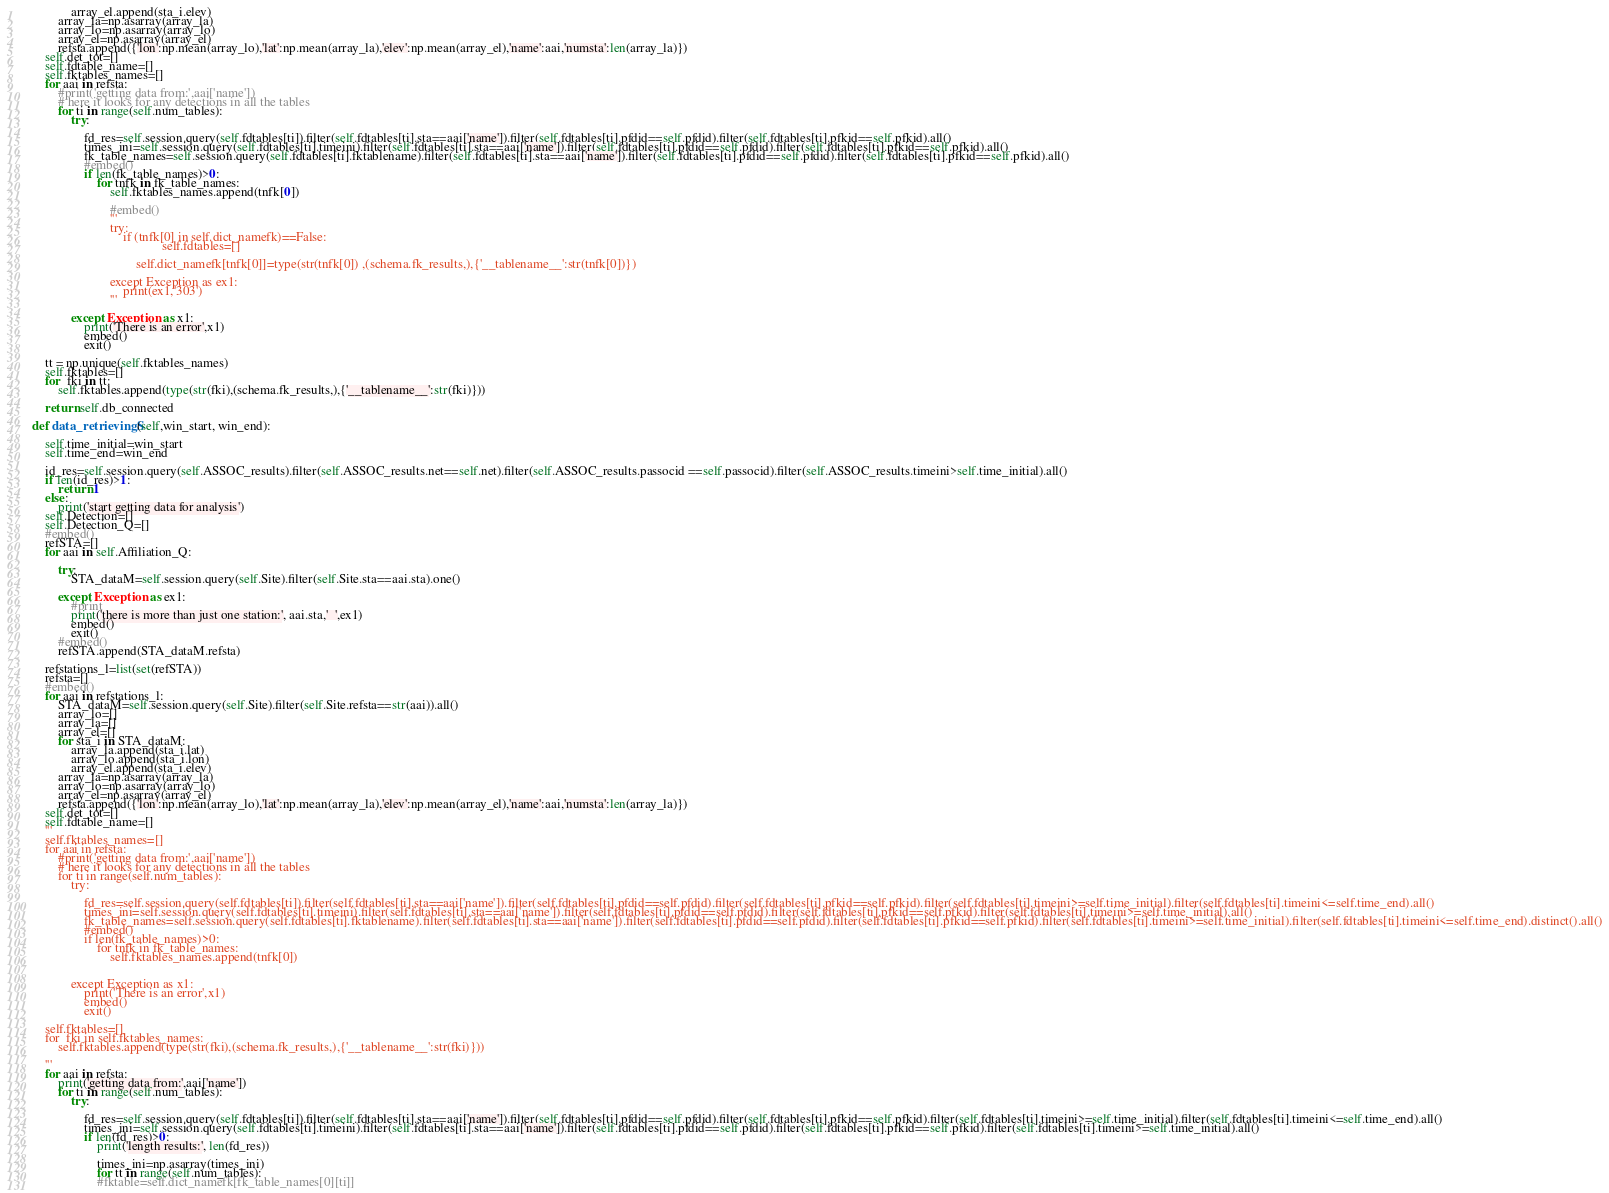<code> <loc_0><loc_0><loc_500><loc_500><_Python_>                array_el.append(sta_i.elev)
            array_la=np.asarray(array_la)
            array_lo=np.asarray(array_lo)
            array_el=np.asarray(array_el)
            refsta.append({'lon':np.mean(array_lo),'lat':np.mean(array_la),'elev':np.mean(array_el),'name':aai,'numsta':len(array_la)})
        self.det_tot=[]
        self.fdtable_name=[]
        self.fktables_names=[]
        for aai in refsta:
            #print('getting data from:',aai['name'])
            # here it looks for any detections in all the tables
            for ti in range(self.num_tables):
                try:

                    fd_res=self.session.query(self.fdtables[ti]).filter(self.fdtables[ti].sta==aai['name']).filter(self.fdtables[ti].pfdid==self.pfdid).filter(self.fdtables[ti].pfkid==self.pfkid).all()
                    times_ini=self.session.query(self.fdtables[ti].timeini).filter(self.fdtables[ti].sta==aai['name']).filter(self.fdtables[ti].pfdid==self.pfdid).filter(self.fdtables[ti].pfkid==self.pfkid).all()
                    fk_table_names=self.session.query(self.fdtables[ti].fktablename).filter(self.fdtables[ti].sta==aai['name']).filter(self.fdtables[ti].pfdid==self.pfdid).filter(self.fdtables[ti].pfkid==self.pfkid).all()
                    #embed()
                    if len(fk_table_names)>0:
                        for tnfk in fk_table_names:
                            self.fktables_names.append(tnfk[0])

                            #embed()
                            '''
                            try:
                                if (tnfk[0] in self.dict_namefk)==False:
                                            self.fdtables=[]

                                    self.dict_namefk[tnfk[0]]=type(str(tnfk[0]) ,(schema.fk_results,),{'__tablename__':str(tnfk[0])})

                            except Exception as ex1:
                                print(ex1,'303')
                            '''

                except Exception as x1:
                    print('There is an error',x1)
                    embed()
                    exit()

        tt = np.unique(self.fktables_names)
        self.fktables=[]
        for  fki in tt:
            self.fktables.append(type(str(fki),(schema.fk_results,),{'__tablename__':str(fki)}))

        return self.db_connected

    def data_retrievingS(self,win_start, win_end):

        self.time_initial=win_start
        self.time_end=win_end

        id_res=self.session.query(self.ASSOC_results).filter(self.ASSOC_results.net==self.net).filter(self.ASSOC_results.passocid ==self.passocid).filter(self.ASSOC_results.timeini>self.time_initial).all()
        if len(id_res)>1:
            return 1
        else:
            print('start getting data for analysis')
        self.Detection=[]
        self.Detection_Q=[]
        #embed()
        refSTA=[]
        for aai in self.Affiliation_Q:

            try:
                STA_dataM=self.session.query(self.Site).filter(self.Site.sta==aai.sta).one()

            except Exception as ex1:
                #print
                print('there is more than just one station:', aai.sta,'  ',ex1)
                embed()
                exit()
            #embed()
            refSTA.append(STA_dataM.refsta)

        refstations_l=list(set(refSTA))
        refsta=[]
        #embed()
        for aai in refstations_l:
            STA_dataM=self.session.query(self.Site).filter(self.Site.refsta==str(aai)).all()
            array_lo=[]
            array_la=[]
            array_el=[]
            for sta_i in STA_dataM:
                array_la.append(sta_i.lat)
                array_lo.append(sta_i.lon)
                array_el.append(sta_i.elev)
            array_la=np.asarray(array_la)
            array_lo=np.asarray(array_lo)
            array_el=np.asarray(array_el)
            refsta.append({'lon':np.mean(array_lo),'lat':np.mean(array_la),'elev':np.mean(array_el),'name':aai,'numsta':len(array_la)})
        self.det_tot=[]
        self.fdtable_name=[]
        '''
        self.fktables_names=[]
        for aai in refsta:
            #print('getting data from:',aai['name'])
            # here it looks for any detections in all the tables
            for ti in range(self.num_tables):
                try:

                    fd_res=self.session.query(self.fdtables[ti]).filter(self.fdtables[ti].sta==aai['name']).filter(self.fdtables[ti].pfdid==self.pfdid).filter(self.fdtables[ti].pfkid==self.pfkid).filter(self.fdtables[ti].timeini>=self.time_initial).filter(self.fdtables[ti].timeini<=self.time_end).all()
                    times_ini=self.session.query(self.fdtables[ti].timeini).filter(self.fdtables[ti].sta==aai['name']).filter(self.fdtables[ti].pfdid==self.pfdid).filter(self.fdtables[ti].pfkid==self.pfkid).filter(self.fdtables[ti].timeini>=self.time_initial).all()
                    fk_table_names=self.session.query(self.fdtables[ti].fktablename).filter(self.fdtables[ti].sta==aai['name']).filter(self.fdtables[ti].pfdid==self.pfdid).filter(self.fdtables[ti].pfkid==self.pfkid).filter(self.fdtables[ti].timeini>=self.time_initial).filter(self.fdtables[ti].timeini<=self.time_end).distinct().all()
                    #embed()
                    if len(fk_table_names)>0:
                        for tnfk in fk_table_names:
                            self.fktables_names.append(tnfk[0])


                except Exception as x1:
                    print('There is an error',x1)
                    embed()
                    exit()

        self.fktables=[]
        for  fki in self.fktables_names:
            self.fktables.append(type(str(fki),(schema.fk_results,),{'__tablename__':str(fki)}))

        '''
        for aai in refsta:
            print('getting data from:',aai['name'])
            for ti in range(self.num_tables):
                try:

                    fd_res=self.session.query(self.fdtables[ti]).filter(self.fdtables[ti].sta==aai['name']).filter(self.fdtables[ti].pfdid==self.pfdid).filter(self.fdtables[ti].pfkid==self.pfkid).filter(self.fdtables[ti].timeini>=self.time_initial).filter(self.fdtables[ti].timeini<=self.time_end).all()
                    times_ini=self.session.query(self.fdtables[ti].timeini).filter(self.fdtables[ti].sta==aai['name']).filter(self.fdtables[ti].pfdid==self.pfdid).filter(self.fdtables[ti].pfkid==self.pfkid).filter(self.fdtables[ti].timeini>=self.time_initial).all()
                    if len(fd_res)>0:
                        print('length results:', len(fd_res))

                        times_ini=np.asarray(times_ini)
                        for tt in range(self.num_tables):
                        #fktable=self.dict_namefk[fk_table_names[0][ti]]</code> 